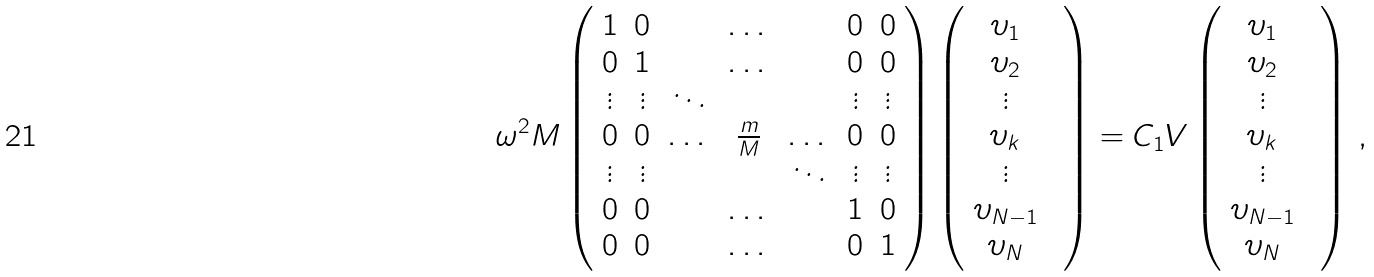<formula> <loc_0><loc_0><loc_500><loc_500>\omega ^ { 2 } M \left ( \begin{array} { c c c c c c c } 1 & 0 & & \dots & & 0 & 0 \\ 0 & 1 & & \dots & & 0 & 0 \\ \vdots & \vdots & \ddots & & & \vdots & \vdots \\ 0 & 0 & \dots & \frac { m } { M } & \dots & 0 & 0 \\ \vdots & \vdots & & & \ddots & \vdots & \vdots \\ 0 & 0 & & \dots & & 1 & 0 \\ 0 & 0 & & \dots & & 0 & 1 \end{array} \right ) \left ( \begin{array} { c c c c c c } \upsilon _ { 1 } & \\ \upsilon _ { 2 } & \\ \vdots & \\ \upsilon _ { k } & \\ \vdots & \\ \upsilon _ { N - 1 } & \\ \upsilon _ { N } & \end{array} \right ) = C _ { 1 } V \left ( \begin{array} { c c c c c c } \upsilon _ { 1 } & \\ \upsilon _ { 2 } & \\ \vdots & \\ \upsilon _ { k } & \\ \vdots & \\ \upsilon _ { N - 1 } & \\ \upsilon _ { N } & \end{array} \right ) \, ,</formula> 